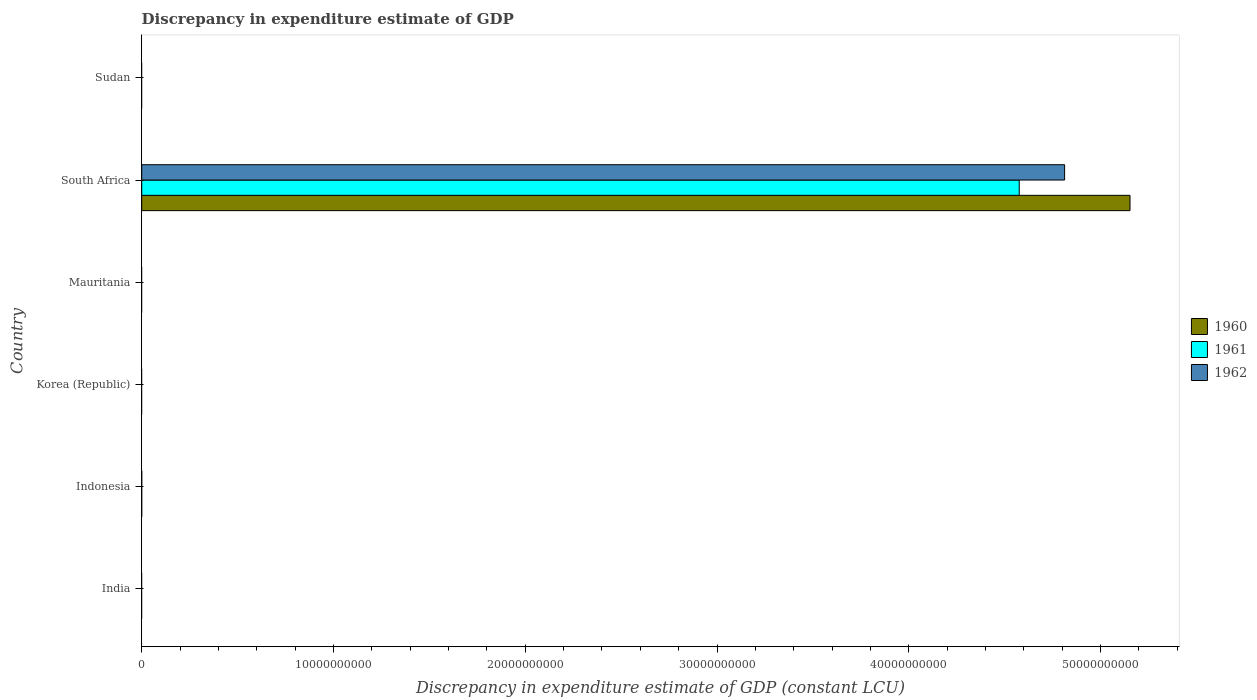How many bars are there on the 6th tick from the top?
Offer a very short reply. 0. How many bars are there on the 2nd tick from the bottom?
Ensure brevity in your answer.  0. What is the label of the 3rd group of bars from the top?
Offer a terse response. Mauritania. In how many cases, is the number of bars for a given country not equal to the number of legend labels?
Ensure brevity in your answer.  5. What is the discrepancy in expenditure estimate of GDP in 1960 in Sudan?
Your answer should be compact. 0. Across all countries, what is the maximum discrepancy in expenditure estimate of GDP in 1960?
Keep it short and to the point. 5.15e+1. In which country was the discrepancy in expenditure estimate of GDP in 1960 maximum?
Ensure brevity in your answer.  South Africa. What is the total discrepancy in expenditure estimate of GDP in 1962 in the graph?
Offer a very short reply. 4.81e+1. What is the difference between the discrepancy in expenditure estimate of GDP in 1962 in Indonesia and the discrepancy in expenditure estimate of GDP in 1960 in Korea (Republic)?
Your response must be concise. 0. What is the average discrepancy in expenditure estimate of GDP in 1961 per country?
Ensure brevity in your answer.  7.63e+09. What is the difference between the discrepancy in expenditure estimate of GDP in 1961 and discrepancy in expenditure estimate of GDP in 1962 in South Africa?
Your response must be concise. -2.37e+09. In how many countries, is the discrepancy in expenditure estimate of GDP in 1962 greater than 52000000000 LCU?
Your response must be concise. 0. What is the difference between the highest and the lowest discrepancy in expenditure estimate of GDP in 1960?
Ensure brevity in your answer.  5.15e+1. Are all the bars in the graph horizontal?
Provide a succinct answer. Yes. How many countries are there in the graph?
Your answer should be compact. 6. What is the difference between two consecutive major ticks on the X-axis?
Your answer should be very brief. 1.00e+1. Are the values on the major ticks of X-axis written in scientific E-notation?
Your answer should be very brief. No. Does the graph contain any zero values?
Provide a succinct answer. Yes. Where does the legend appear in the graph?
Offer a very short reply. Center right. How are the legend labels stacked?
Provide a short and direct response. Vertical. What is the title of the graph?
Your answer should be compact. Discrepancy in expenditure estimate of GDP. What is the label or title of the X-axis?
Make the answer very short. Discrepancy in expenditure estimate of GDP (constant LCU). What is the label or title of the Y-axis?
Keep it short and to the point. Country. What is the Discrepancy in expenditure estimate of GDP (constant LCU) in 1961 in India?
Offer a terse response. 0. What is the Discrepancy in expenditure estimate of GDP (constant LCU) of 1962 in India?
Provide a succinct answer. 0. What is the Discrepancy in expenditure estimate of GDP (constant LCU) in 1962 in Indonesia?
Offer a very short reply. 0. What is the Discrepancy in expenditure estimate of GDP (constant LCU) in 1962 in Korea (Republic)?
Ensure brevity in your answer.  0. What is the Discrepancy in expenditure estimate of GDP (constant LCU) of 1961 in Mauritania?
Ensure brevity in your answer.  0. What is the Discrepancy in expenditure estimate of GDP (constant LCU) of 1960 in South Africa?
Give a very brief answer. 5.15e+1. What is the Discrepancy in expenditure estimate of GDP (constant LCU) in 1961 in South Africa?
Provide a succinct answer. 4.58e+1. What is the Discrepancy in expenditure estimate of GDP (constant LCU) in 1962 in South Africa?
Give a very brief answer. 4.81e+1. What is the Discrepancy in expenditure estimate of GDP (constant LCU) of 1960 in Sudan?
Provide a succinct answer. 0. What is the Discrepancy in expenditure estimate of GDP (constant LCU) of 1961 in Sudan?
Your answer should be compact. 0. What is the Discrepancy in expenditure estimate of GDP (constant LCU) in 1962 in Sudan?
Offer a very short reply. 0. Across all countries, what is the maximum Discrepancy in expenditure estimate of GDP (constant LCU) of 1960?
Offer a terse response. 5.15e+1. Across all countries, what is the maximum Discrepancy in expenditure estimate of GDP (constant LCU) of 1961?
Keep it short and to the point. 4.58e+1. Across all countries, what is the maximum Discrepancy in expenditure estimate of GDP (constant LCU) of 1962?
Your answer should be compact. 4.81e+1. Across all countries, what is the minimum Discrepancy in expenditure estimate of GDP (constant LCU) in 1960?
Your answer should be very brief. 0. Across all countries, what is the minimum Discrepancy in expenditure estimate of GDP (constant LCU) in 1961?
Your answer should be compact. 0. Across all countries, what is the minimum Discrepancy in expenditure estimate of GDP (constant LCU) in 1962?
Your response must be concise. 0. What is the total Discrepancy in expenditure estimate of GDP (constant LCU) in 1960 in the graph?
Provide a succinct answer. 5.15e+1. What is the total Discrepancy in expenditure estimate of GDP (constant LCU) of 1961 in the graph?
Offer a terse response. 4.58e+1. What is the total Discrepancy in expenditure estimate of GDP (constant LCU) in 1962 in the graph?
Provide a short and direct response. 4.81e+1. What is the average Discrepancy in expenditure estimate of GDP (constant LCU) of 1960 per country?
Make the answer very short. 8.59e+09. What is the average Discrepancy in expenditure estimate of GDP (constant LCU) in 1961 per country?
Provide a short and direct response. 7.63e+09. What is the average Discrepancy in expenditure estimate of GDP (constant LCU) in 1962 per country?
Give a very brief answer. 8.02e+09. What is the difference between the Discrepancy in expenditure estimate of GDP (constant LCU) of 1960 and Discrepancy in expenditure estimate of GDP (constant LCU) of 1961 in South Africa?
Offer a terse response. 5.78e+09. What is the difference between the Discrepancy in expenditure estimate of GDP (constant LCU) in 1960 and Discrepancy in expenditure estimate of GDP (constant LCU) in 1962 in South Africa?
Offer a terse response. 3.41e+09. What is the difference between the Discrepancy in expenditure estimate of GDP (constant LCU) in 1961 and Discrepancy in expenditure estimate of GDP (constant LCU) in 1962 in South Africa?
Give a very brief answer. -2.37e+09. What is the difference between the highest and the lowest Discrepancy in expenditure estimate of GDP (constant LCU) in 1960?
Make the answer very short. 5.15e+1. What is the difference between the highest and the lowest Discrepancy in expenditure estimate of GDP (constant LCU) in 1961?
Provide a succinct answer. 4.58e+1. What is the difference between the highest and the lowest Discrepancy in expenditure estimate of GDP (constant LCU) in 1962?
Keep it short and to the point. 4.81e+1. 